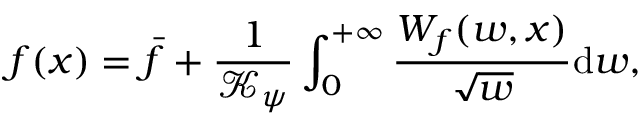<formula> <loc_0><loc_0><loc_500><loc_500>f ( x ) = \bar { f } + \frac { 1 } { \mathcal { K } _ { \psi } } \int _ { 0 } ^ { + \infty } \frac { W _ { f } ( w , x ) } { \sqrt { w } } d w ,</formula> 